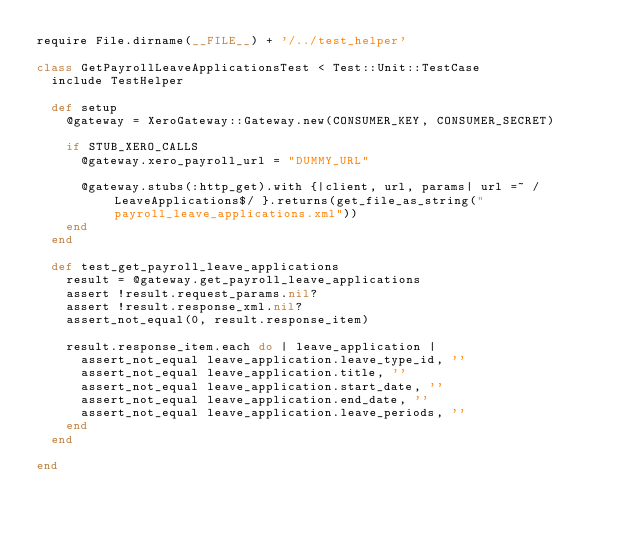<code> <loc_0><loc_0><loc_500><loc_500><_Ruby_>require File.dirname(__FILE__) + '/../test_helper'

class GetPayrollLeaveApplicationsTest < Test::Unit::TestCase
  include TestHelper

  def setup
    @gateway = XeroGateway::Gateway.new(CONSUMER_KEY, CONSUMER_SECRET)

    if STUB_XERO_CALLS
      @gateway.xero_payroll_url = "DUMMY_URL"

      @gateway.stubs(:http_get).with {|client, url, params| url =~ /LeaveApplications$/ }.returns(get_file_as_string("payroll_leave_applications.xml"))
    end
  end

  def test_get_payroll_leave_applications
    result = @gateway.get_payroll_leave_applications
    assert !result.request_params.nil?
    assert !result.response_xml.nil?
    assert_not_equal(0, result.response_item)

    result.response_item.each do | leave_application |
      assert_not_equal leave_application.leave_type_id, ''
      assert_not_equal leave_application.title, ''
      assert_not_equal leave_application.start_date, ''
      assert_not_equal leave_application.end_date, ''
      assert_not_equal leave_application.leave_periods, ''
    end
  end

end</code> 